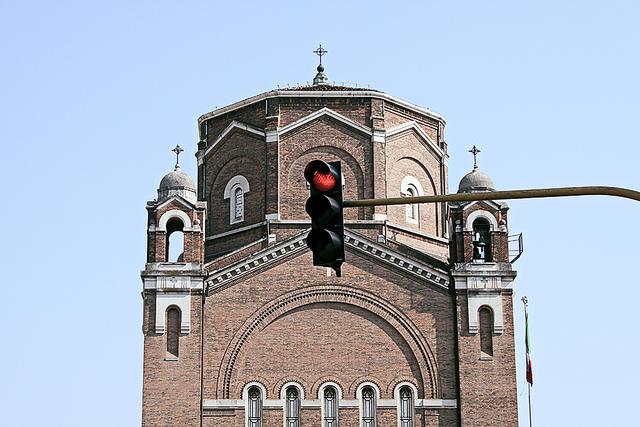What is on top of the building?
Answer briefly. Cross. What does the red light mean?
Write a very short answer. Stop. What color is the traffic light?
Keep it brief. Red. 